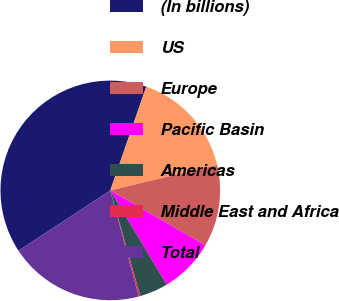<chart> <loc_0><loc_0><loc_500><loc_500><pie_chart><fcel>(In billions)<fcel>US<fcel>Europe<fcel>Pacific Basin<fcel>Americas<fcel>Middle East and Africa<fcel>Total<nl><fcel>39.57%<fcel>15.97%<fcel>12.04%<fcel>8.1%<fcel>4.17%<fcel>0.24%<fcel>19.91%<nl></chart> 